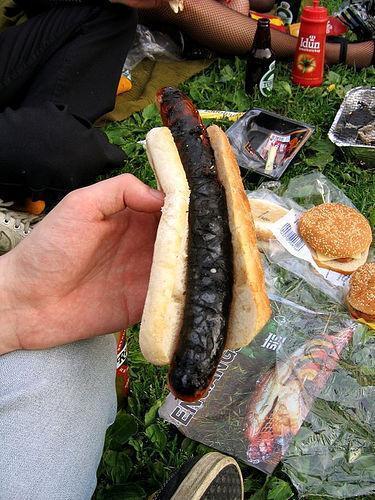How many hot dogs are there?
Give a very brief answer. 1. How many people can be seen?
Give a very brief answer. 3. How many big bear are there in the image?
Give a very brief answer. 0. 